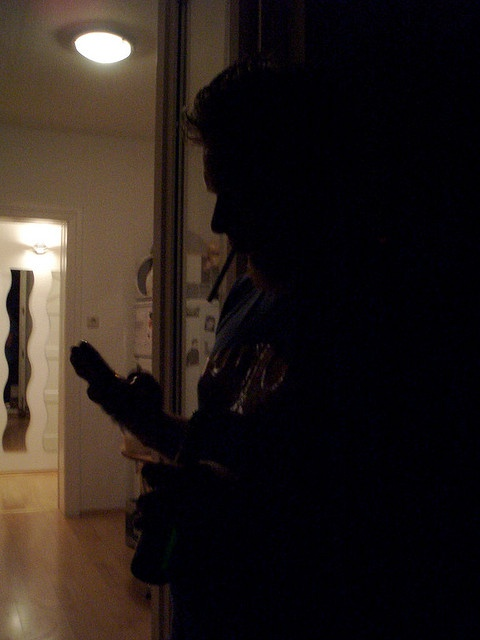Describe the objects in this image and their specific colors. I can see people in black, maroon, and brown tones, refrigerator in black, maroon, and brown tones, and cell phone in black, maroon, and brown tones in this image. 